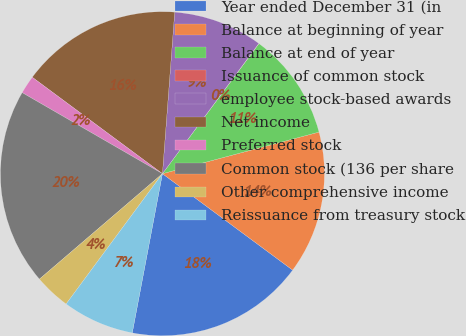<chart> <loc_0><loc_0><loc_500><loc_500><pie_chart><fcel>Year ended December 31 (in<fcel>Balance at beginning of year<fcel>Balance at end of year<fcel>Issuance of common stock<fcel>employee stock-based awards<fcel>Net income<fcel>Preferred stock<fcel>Common stock (136 per share<fcel>Other comprehensive income<fcel>Reissuance from treasury stock<nl><fcel>17.84%<fcel>14.28%<fcel>10.71%<fcel>0.02%<fcel>8.93%<fcel>16.06%<fcel>1.81%<fcel>19.62%<fcel>3.59%<fcel>7.15%<nl></chart> 